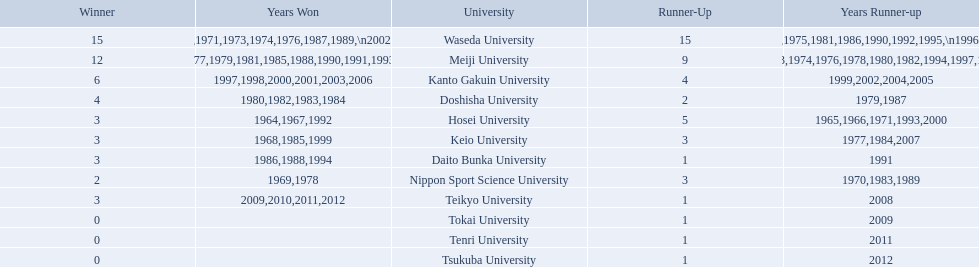What university were there in the all-japan university rugby championship? Waseda University, Meiji University, Kanto Gakuin University, Doshisha University, Hosei University, Keio University, Daito Bunka University, Nippon Sport Science University, Teikyo University, Tokai University, Tenri University, Tsukuba University. Of these who had more than 12 wins? Waseda University. 